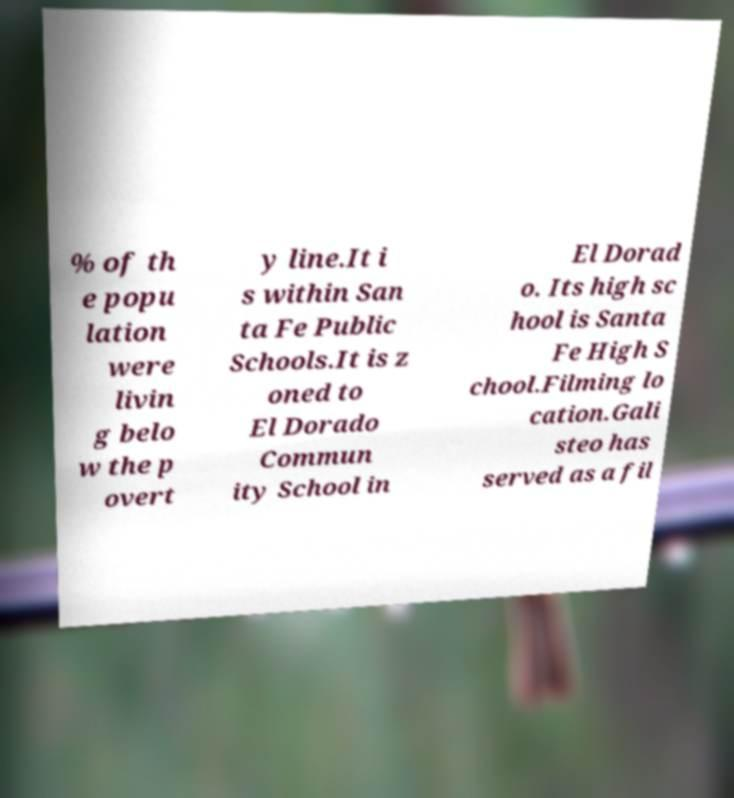Please read and relay the text visible in this image. What does it say? % of th e popu lation were livin g belo w the p overt y line.It i s within San ta Fe Public Schools.It is z oned to El Dorado Commun ity School in El Dorad o. Its high sc hool is Santa Fe High S chool.Filming lo cation.Gali steo has served as a fil 